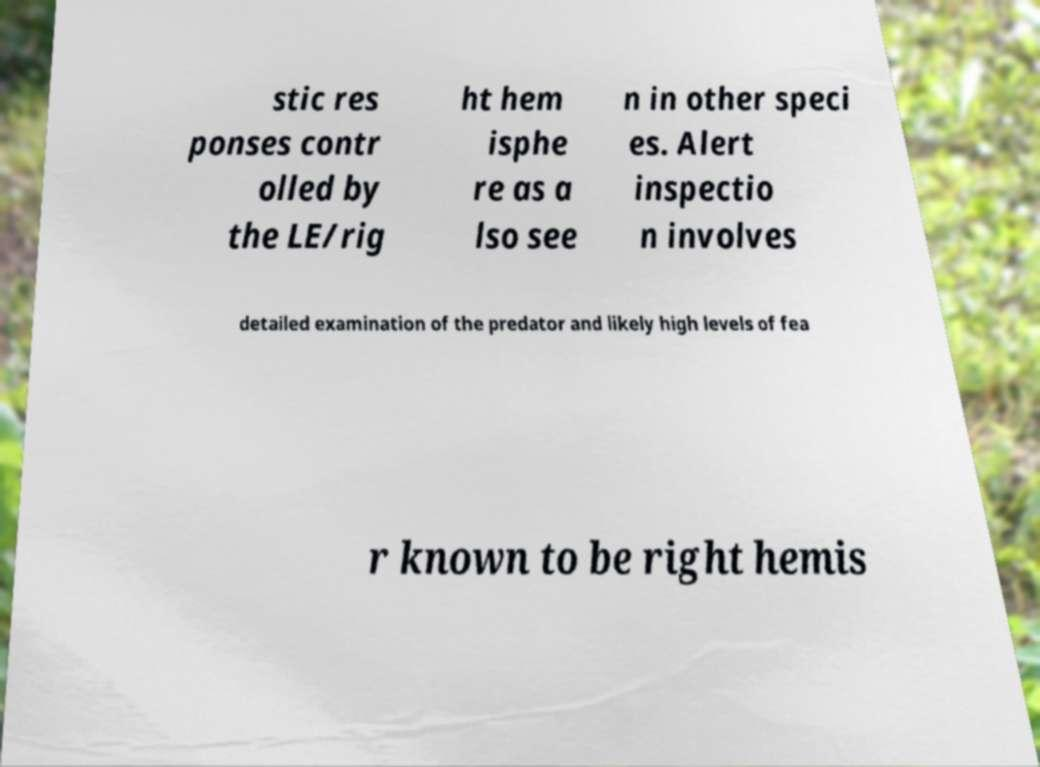There's text embedded in this image that I need extracted. Can you transcribe it verbatim? stic res ponses contr olled by the LE/rig ht hem isphe re as a lso see n in other speci es. Alert inspectio n involves detailed examination of the predator and likely high levels of fea r known to be right hemis 